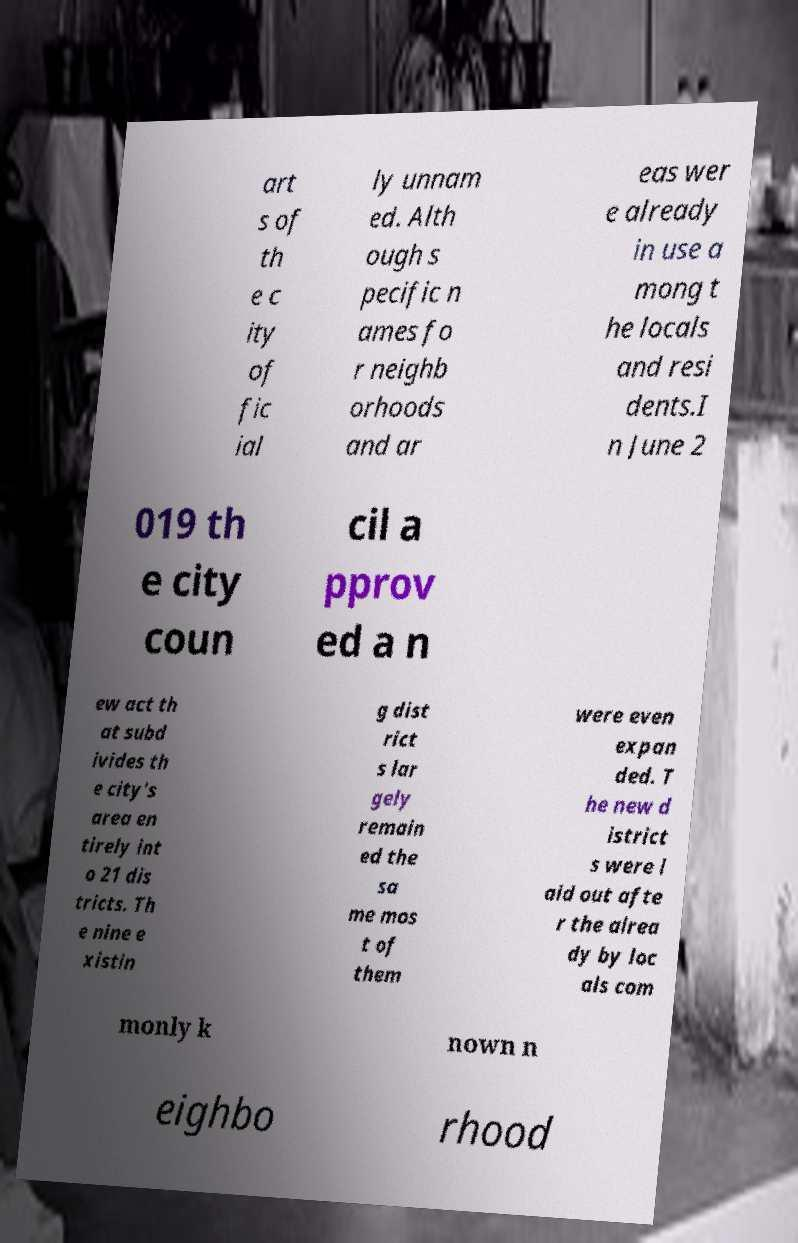Can you read and provide the text displayed in the image?This photo seems to have some interesting text. Can you extract and type it out for me? art s of th e c ity of fic ial ly unnam ed. Alth ough s pecific n ames fo r neighb orhoods and ar eas wer e already in use a mong t he locals and resi dents.I n June 2 019 th e city coun cil a pprov ed a n ew act th at subd ivides th e city's area en tirely int o 21 dis tricts. Th e nine e xistin g dist rict s lar gely remain ed the sa me mos t of them were even expan ded. T he new d istrict s were l aid out afte r the alrea dy by loc als com monly k nown n eighbo rhood 